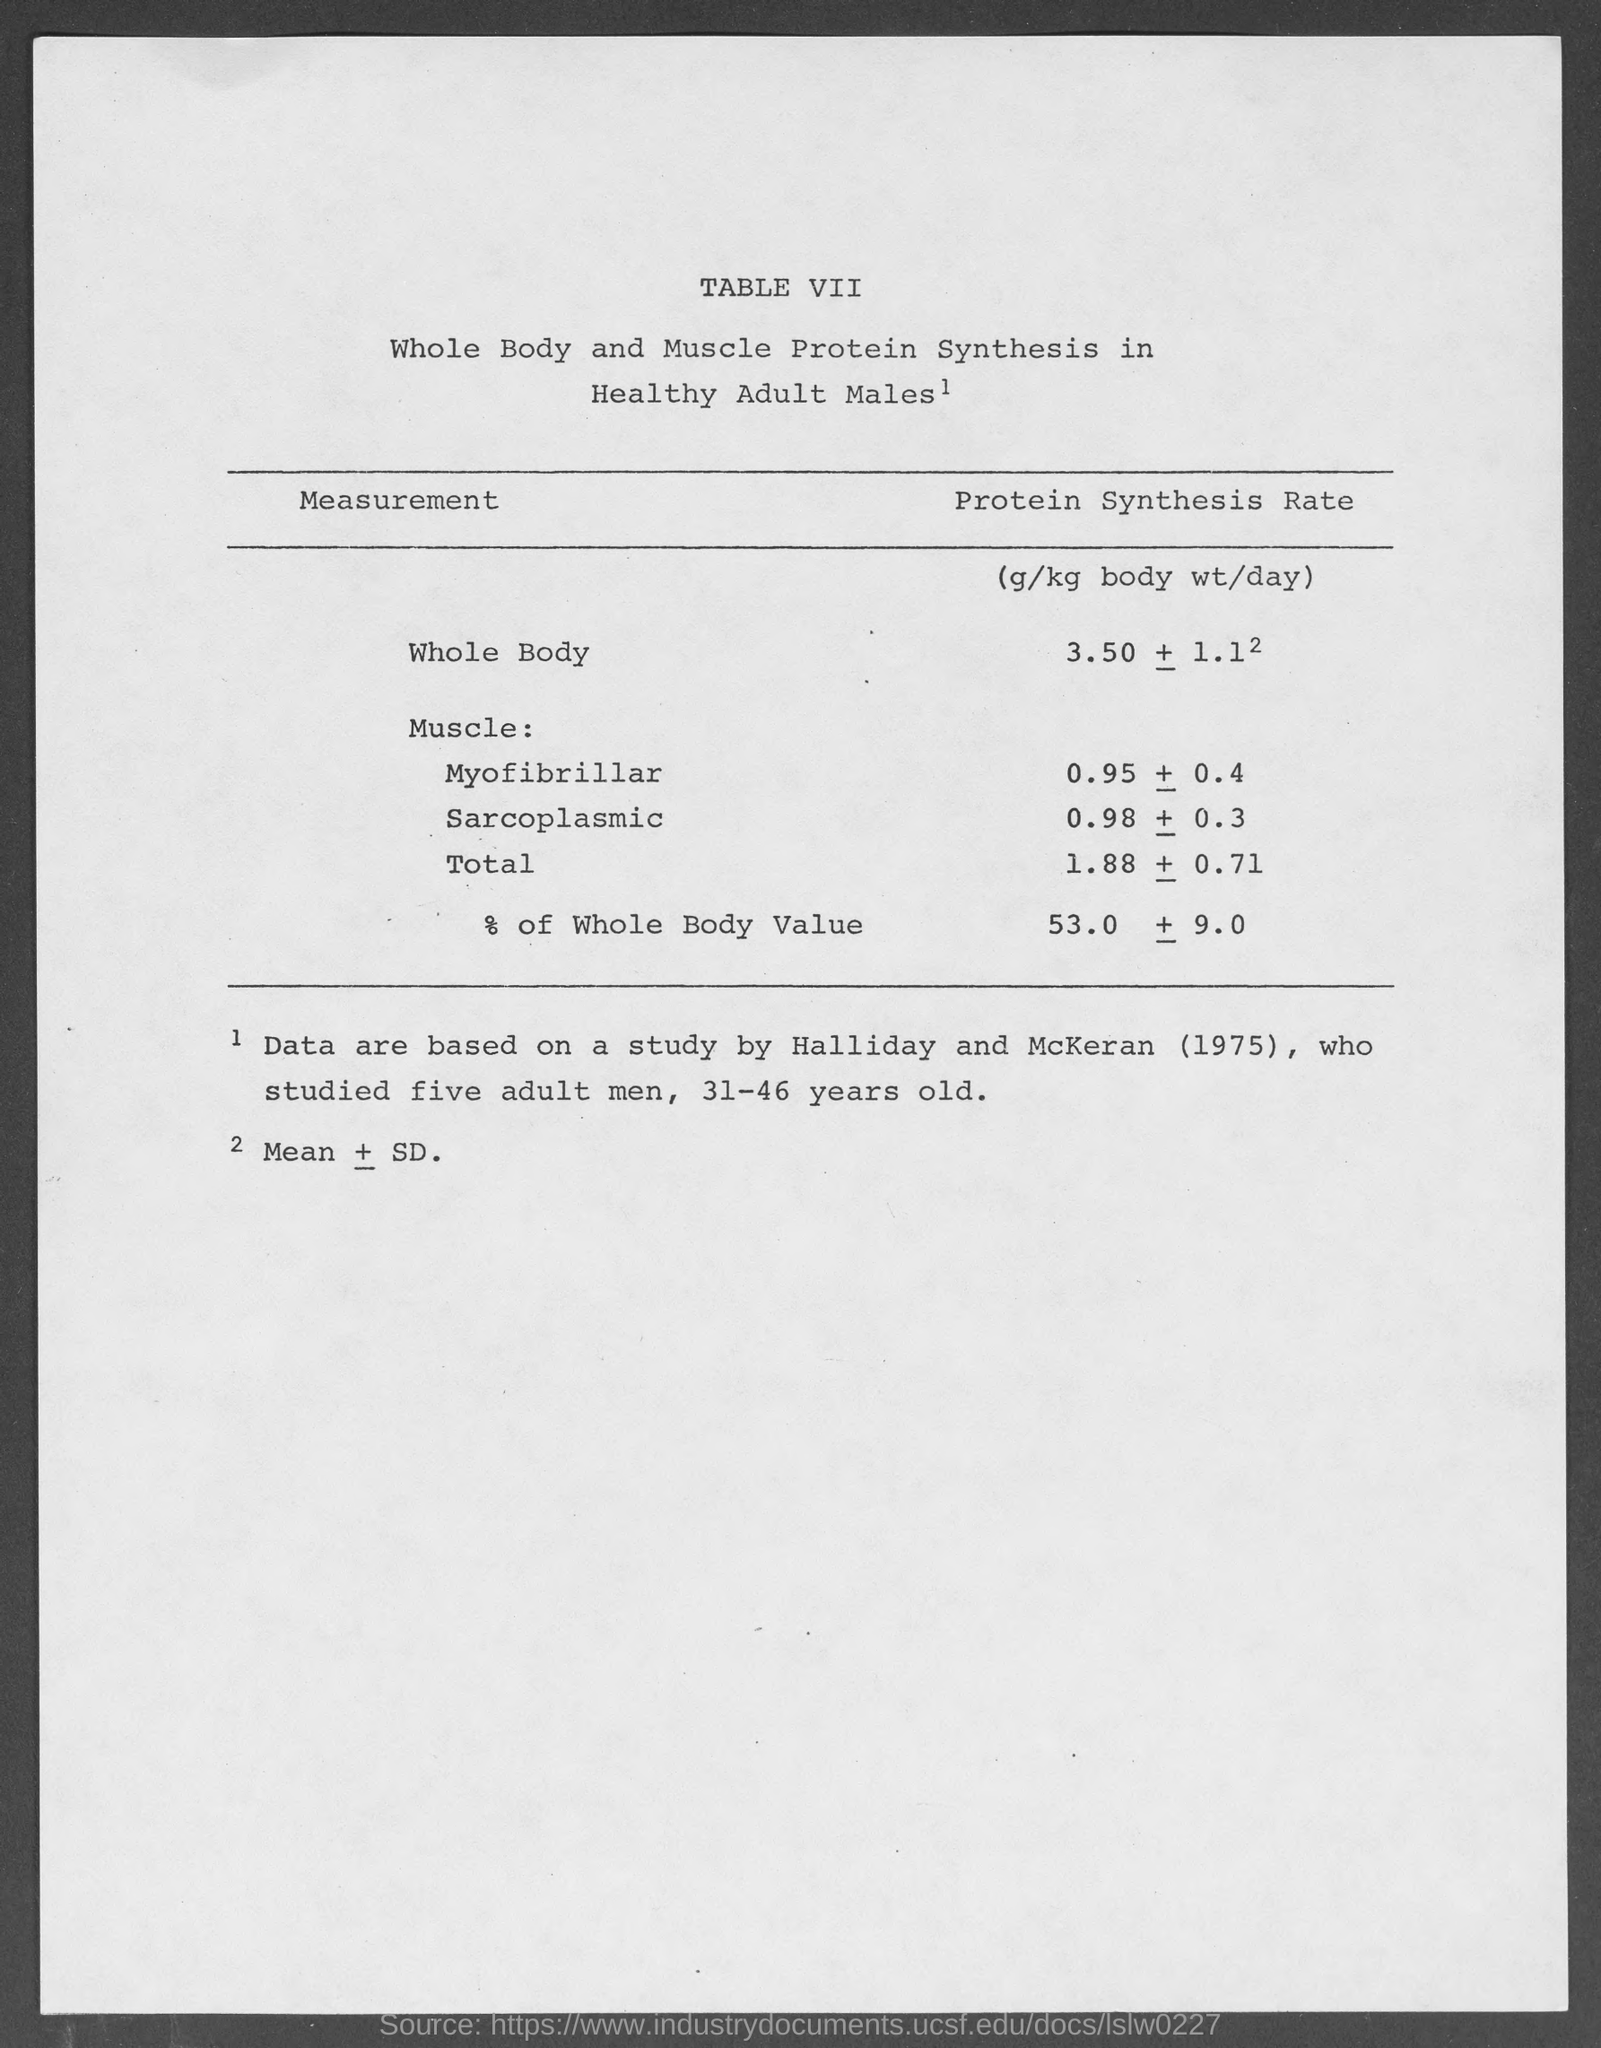What is the table no.?
Ensure brevity in your answer.  VII. 